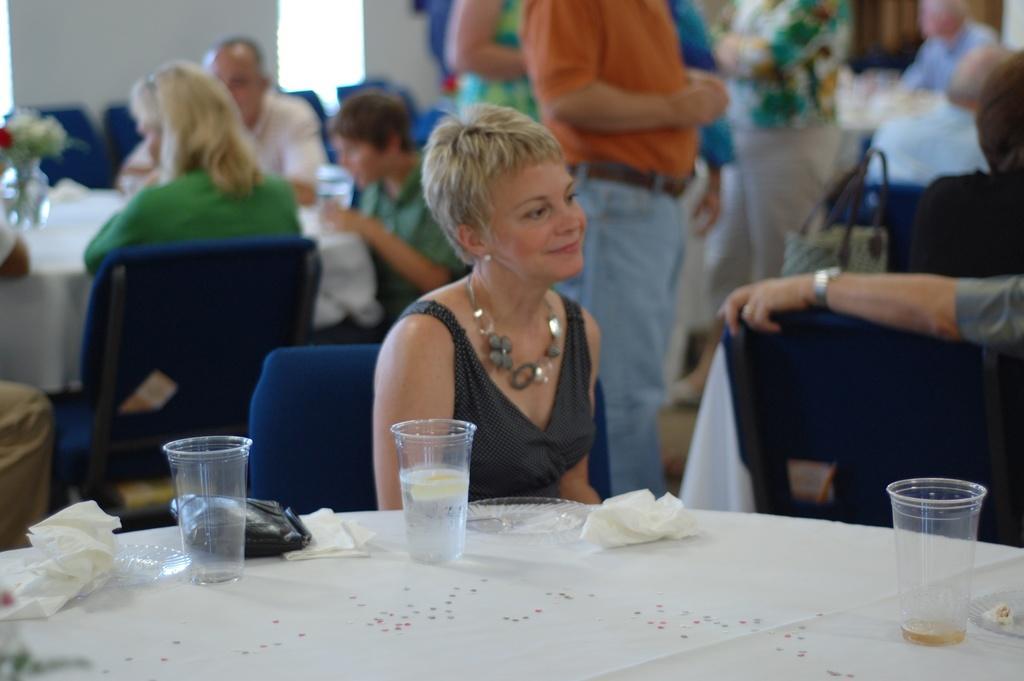Please provide a concise description of this image. In this image there is a woman sitting in the chair , and in table there is tissue, glass , wallet, plate and back ground there are group of people standing , and another group of people sitting in chair, and there is a flower vase in the table. 